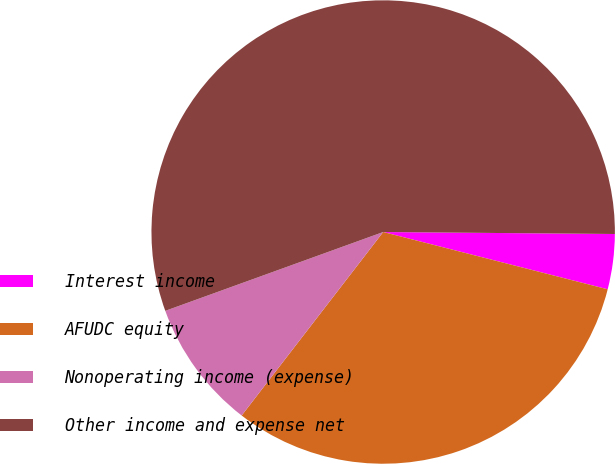<chart> <loc_0><loc_0><loc_500><loc_500><pie_chart><fcel>Interest income<fcel>AFUDC equity<fcel>Nonoperating income (expense)<fcel>Other income and expense net<nl><fcel>3.84%<fcel>31.48%<fcel>9.02%<fcel>55.66%<nl></chart> 